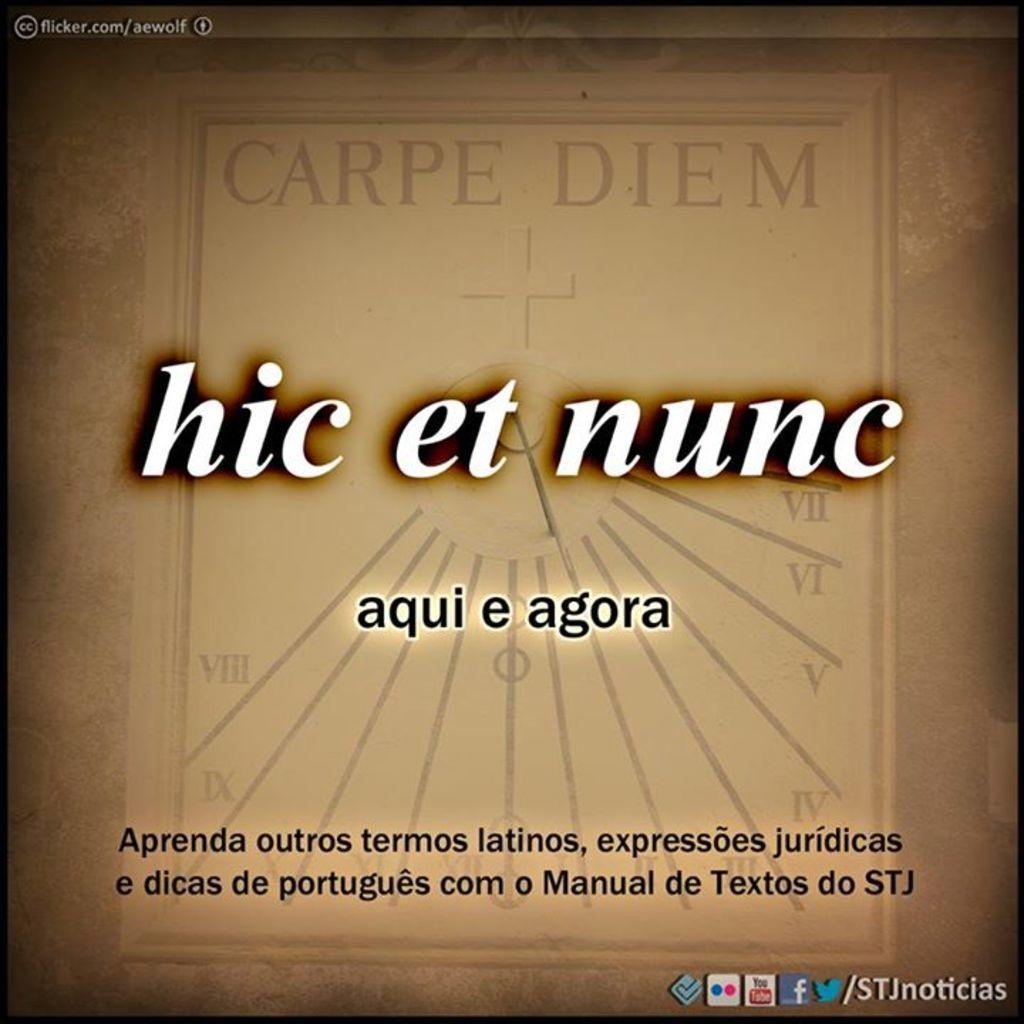<image>
Present a compact description of the photo's key features. Carpe Diem and hic et nunc are written on a tan background with other spanish words. 